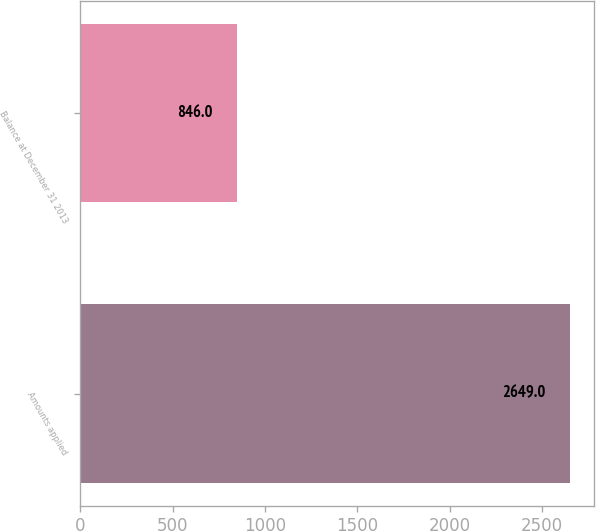<chart> <loc_0><loc_0><loc_500><loc_500><bar_chart><fcel>Amounts applied<fcel>Balance at December 31 2013<nl><fcel>2649<fcel>846<nl></chart> 